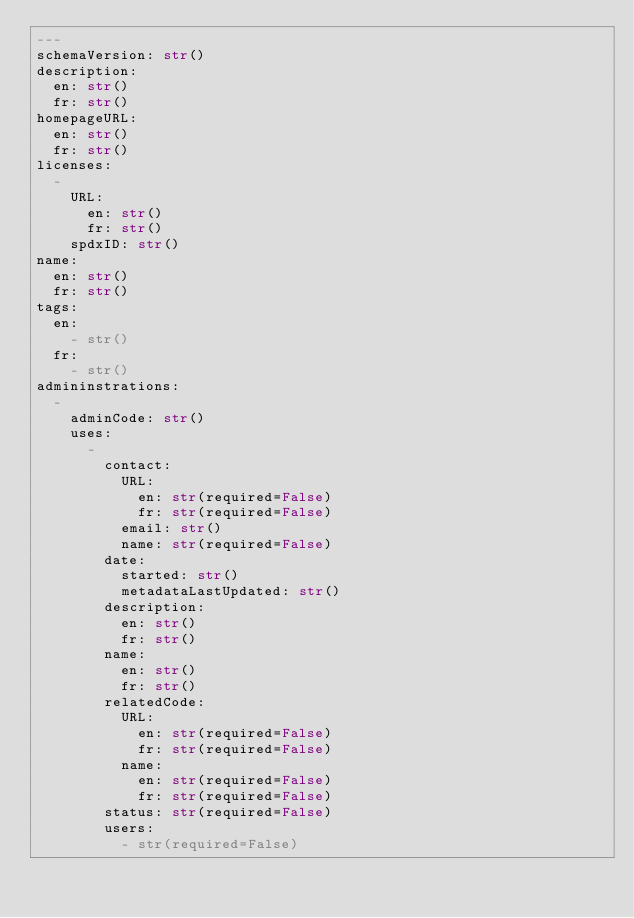<code> <loc_0><loc_0><loc_500><loc_500><_YAML_>--- 
schemaVersion: str()
description: 
  en: str()
  fr: str()
homepageURL:
  en: str()
  fr: str()
licenses: 
  - 
    URL: 
      en: str()
      fr: str()
    spdxID: str()
name: 
  en: str()
  fr: str()
tags: 
  en:
    - str()
  fr: 
    - str()
admininstrations: 
  - 
    adminCode: str()
    uses: 
      - 
        contact: 
          URL: 
            en: str(required=False)
            fr: str(required=False)
          email: str()
          name: str(required=False) 
        date: 
          started: str()
          metadataLastUpdated: str()
        description: 
          en: str()
          fr: str()
        name: 
          en: str()
          fr: str()
        relatedCode:
          URL: 
            en: str(required=False)
            fr: str(required=False)
          name: 
            en: str(required=False)
            fr: str(required=False)
        status: str(required=False)
        users: 
          - str(required=False)</code> 